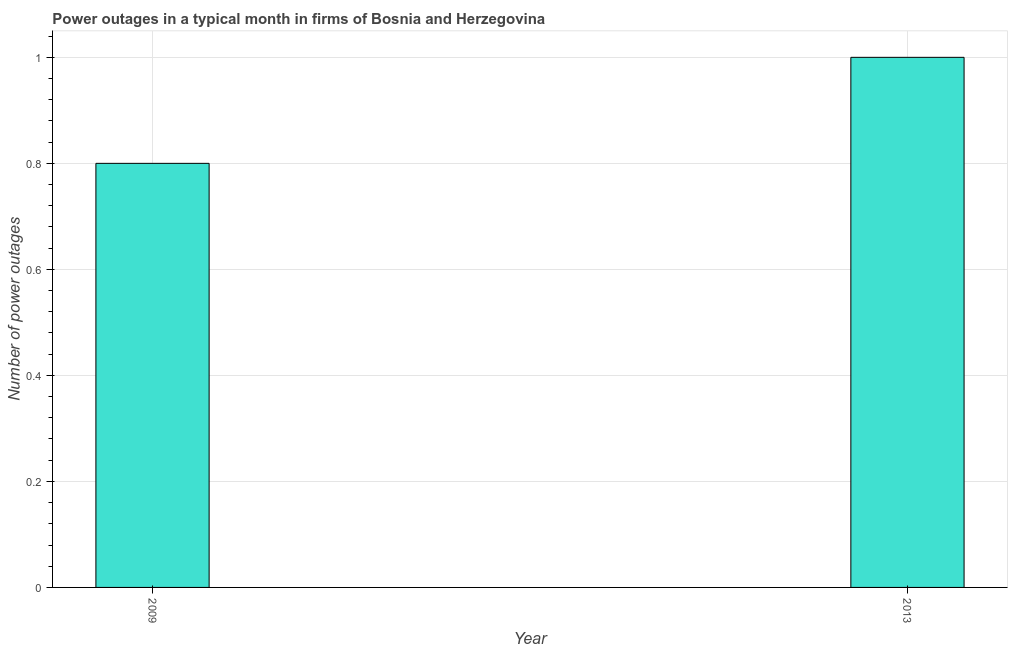Does the graph contain grids?
Make the answer very short. Yes. What is the title of the graph?
Your answer should be compact. Power outages in a typical month in firms of Bosnia and Herzegovina. What is the label or title of the Y-axis?
Make the answer very short. Number of power outages. What is the number of power outages in 2009?
Your answer should be very brief. 0.8. Across all years, what is the maximum number of power outages?
Give a very brief answer. 1. In which year was the number of power outages minimum?
Provide a short and direct response. 2009. What is the sum of the number of power outages?
Ensure brevity in your answer.  1.8. What is the difference between the number of power outages in 2009 and 2013?
Keep it short and to the point. -0.2. What is the median number of power outages?
Your response must be concise. 0.9. Do a majority of the years between 2009 and 2013 (inclusive) have number of power outages greater than 0.2 ?
Your response must be concise. Yes. What is the ratio of the number of power outages in 2009 to that in 2013?
Your answer should be compact. 0.8. In how many years, is the number of power outages greater than the average number of power outages taken over all years?
Provide a succinct answer. 1. Are all the bars in the graph horizontal?
Your answer should be compact. No. What is the difference between two consecutive major ticks on the Y-axis?
Keep it short and to the point. 0.2. Are the values on the major ticks of Y-axis written in scientific E-notation?
Your response must be concise. No. What is the Number of power outages of 2009?
Offer a terse response. 0.8. What is the ratio of the Number of power outages in 2009 to that in 2013?
Provide a succinct answer. 0.8. 